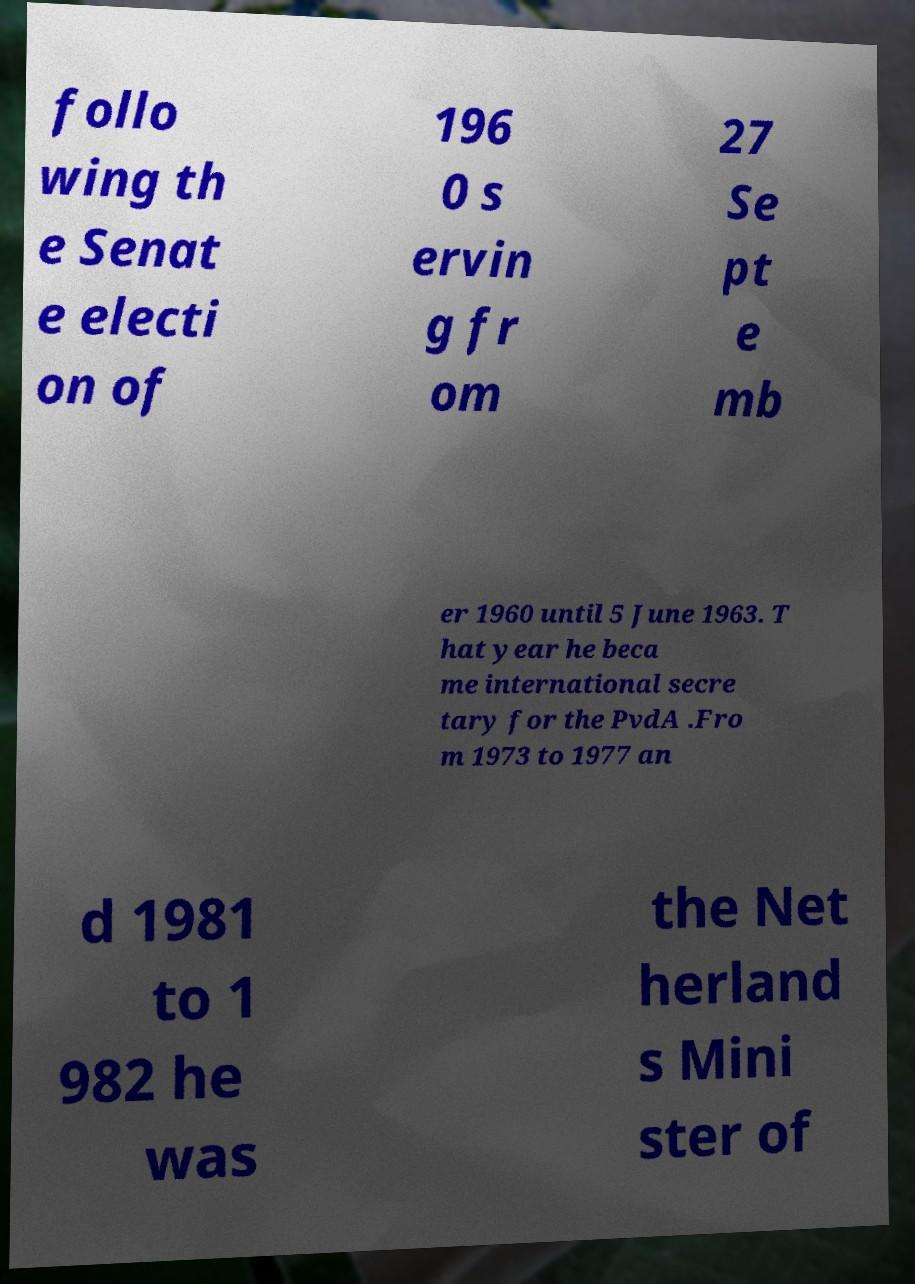Can you read and provide the text displayed in the image?This photo seems to have some interesting text. Can you extract and type it out for me? follo wing th e Senat e electi on of 196 0 s ervin g fr om 27 Se pt e mb er 1960 until 5 June 1963. T hat year he beca me international secre tary for the PvdA .Fro m 1973 to 1977 an d 1981 to 1 982 he was the Net herland s Mini ster of 